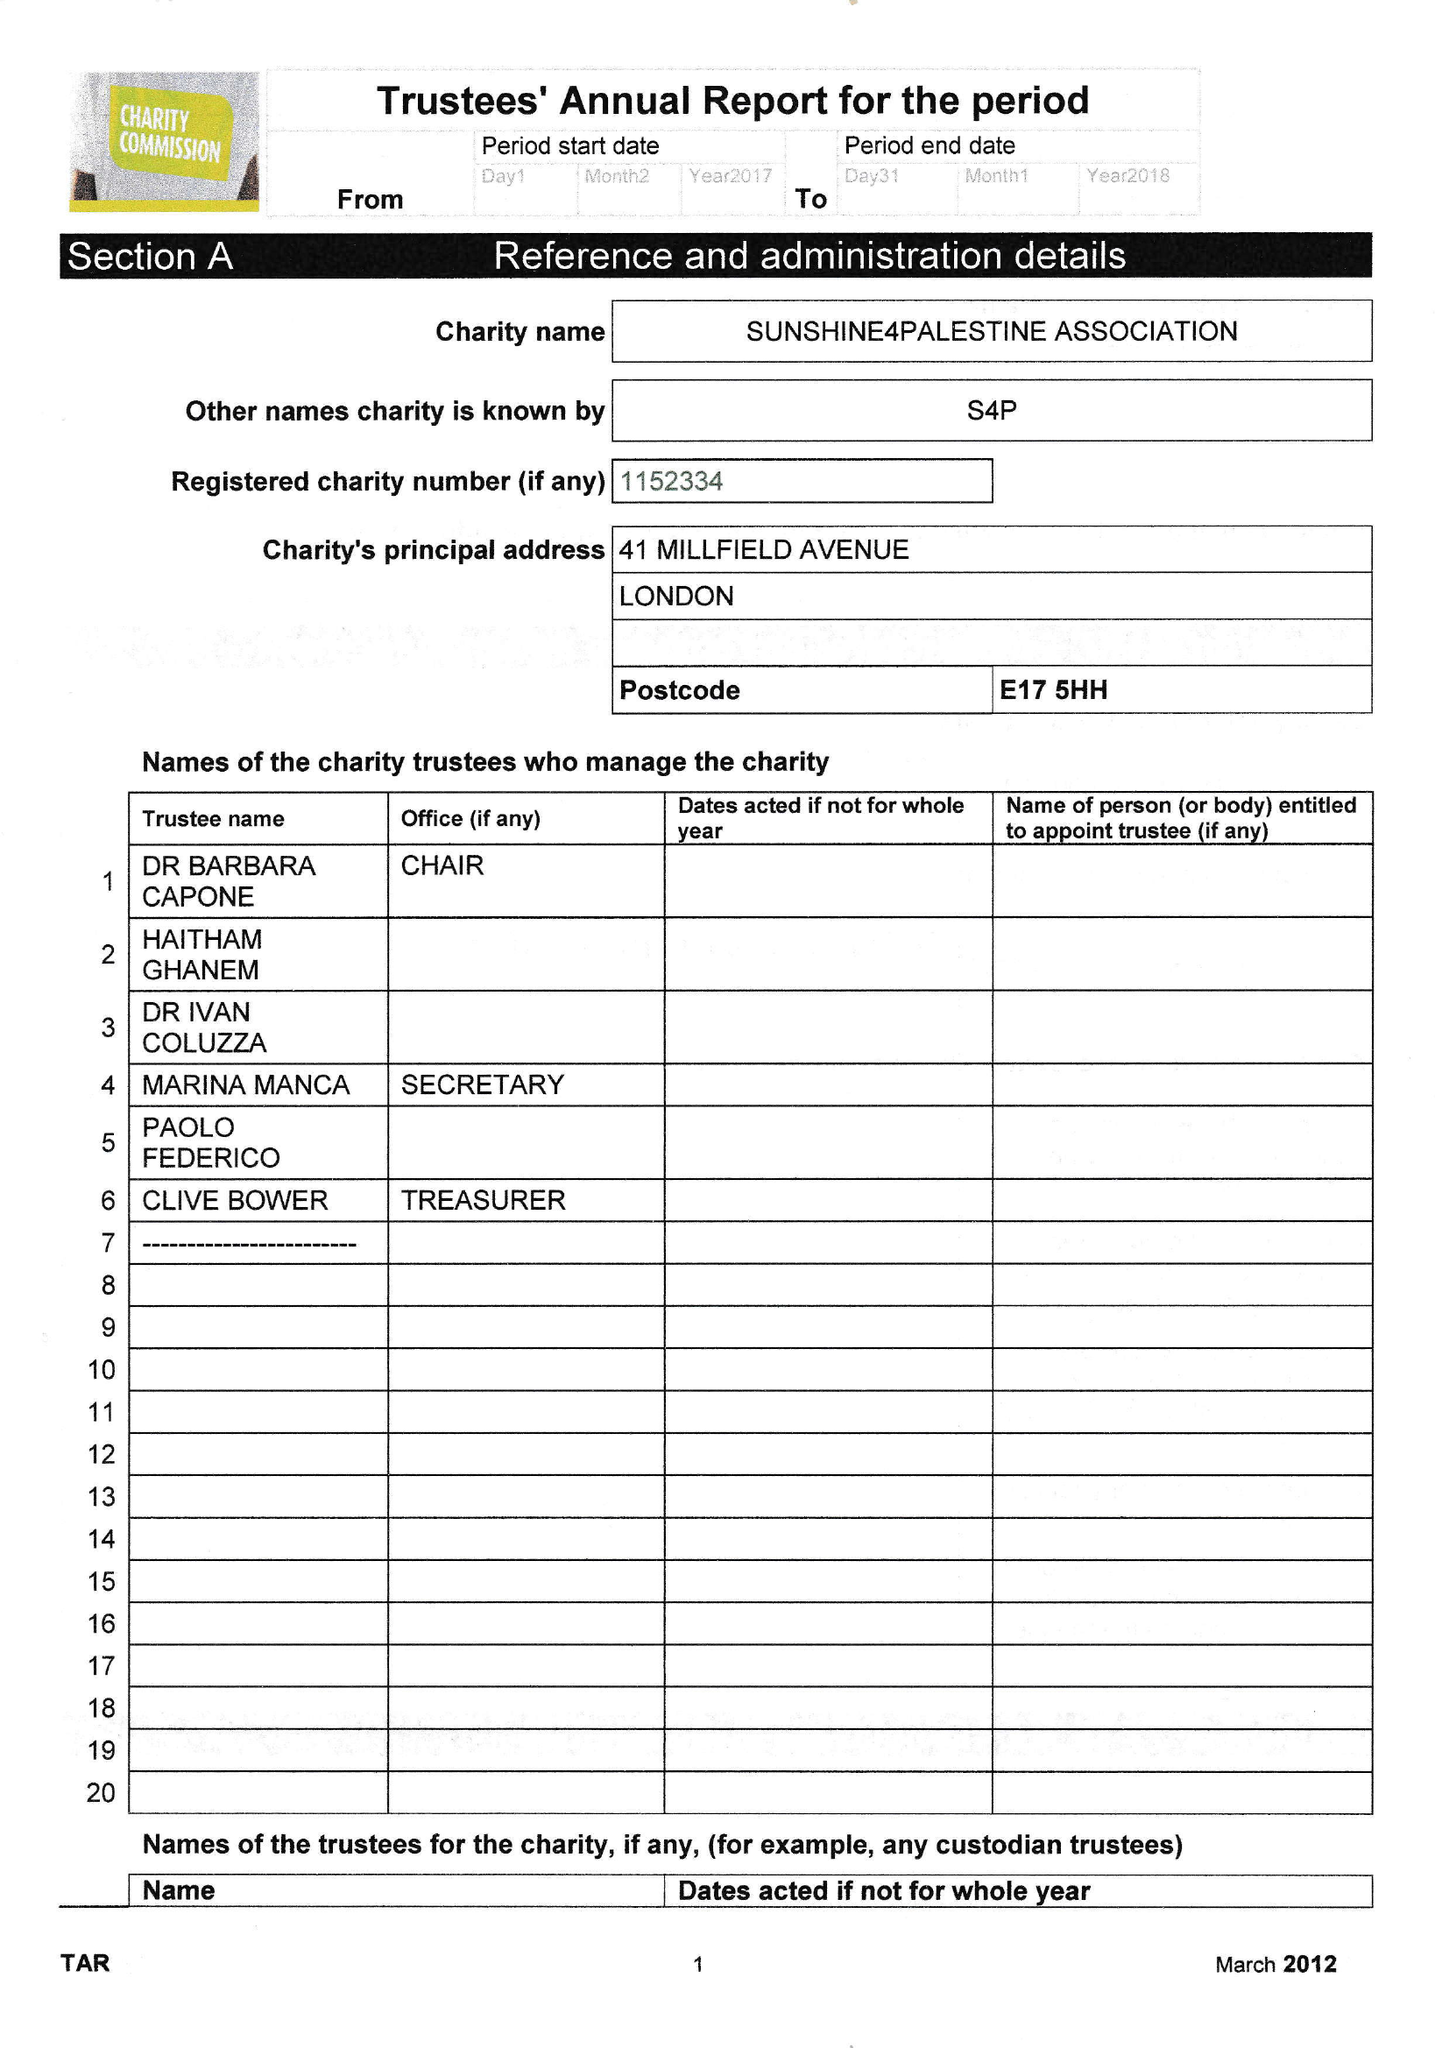What is the value for the income_annually_in_british_pounds?
Answer the question using a single word or phrase. None 